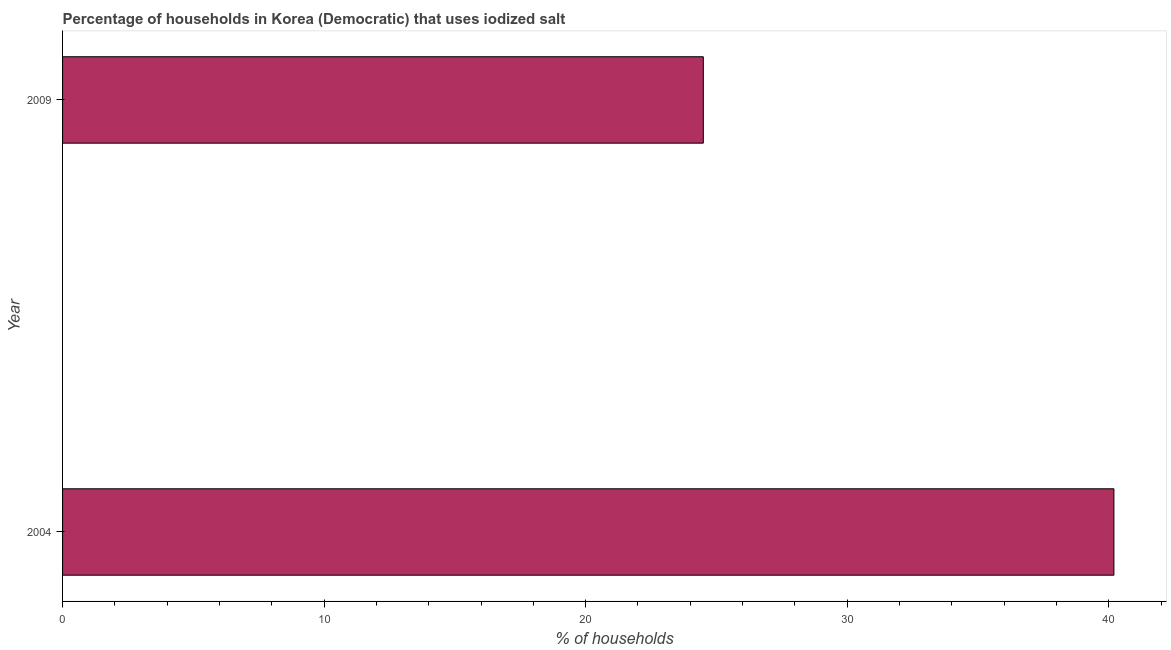Does the graph contain grids?
Provide a succinct answer. No. What is the title of the graph?
Keep it short and to the point. Percentage of households in Korea (Democratic) that uses iodized salt. What is the label or title of the X-axis?
Offer a very short reply. % of households. What is the percentage of households where iodized salt is consumed in 2004?
Offer a terse response. 40.2. Across all years, what is the maximum percentage of households where iodized salt is consumed?
Provide a succinct answer. 40.2. Across all years, what is the minimum percentage of households where iodized salt is consumed?
Provide a succinct answer. 24.5. In which year was the percentage of households where iodized salt is consumed minimum?
Make the answer very short. 2009. What is the sum of the percentage of households where iodized salt is consumed?
Make the answer very short. 64.7. What is the average percentage of households where iodized salt is consumed per year?
Provide a succinct answer. 32.35. What is the median percentage of households where iodized salt is consumed?
Provide a succinct answer. 32.35. What is the ratio of the percentage of households where iodized salt is consumed in 2004 to that in 2009?
Offer a terse response. 1.64. Is the percentage of households where iodized salt is consumed in 2004 less than that in 2009?
Your answer should be very brief. No. How many bars are there?
Your response must be concise. 2. What is the % of households in 2004?
Your answer should be very brief. 40.2. What is the difference between the % of households in 2004 and 2009?
Offer a very short reply. 15.7. What is the ratio of the % of households in 2004 to that in 2009?
Ensure brevity in your answer.  1.64. 